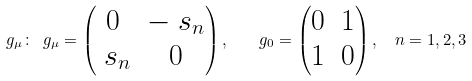<formula> <loc_0><loc_0><loc_500><loc_500>\ g _ { \mu } \colon \ g _ { \mu } = \begin{pmatrix} 0 & - \ s _ { n } \\ \ s _ { n } & 0 \end{pmatrix} , \quad g _ { 0 } = \begin{pmatrix} 0 & 1 \\ 1 & 0 \end{pmatrix} , \ \ n = 1 , 2 , 3</formula> 